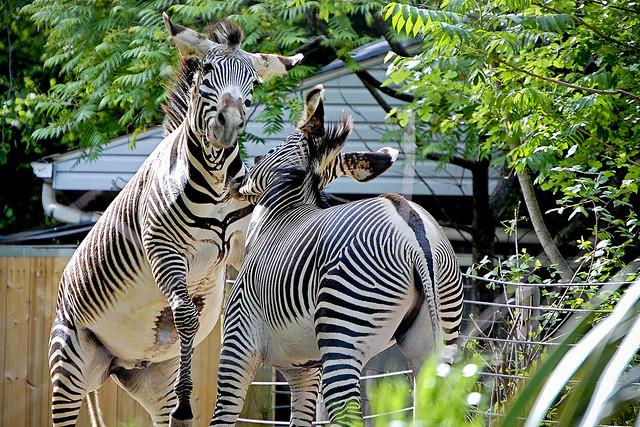Why do zebra  look black and white?
Concise answer only. I don't know. Are the zebra fighting?
Short answer required. Yes. What is the large object behind the zebra?
Quick response, please. House. 